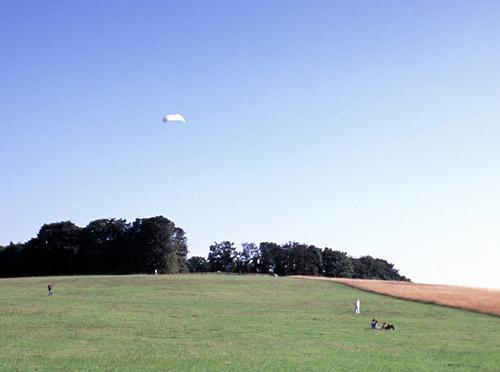How many kites are there?
Give a very brief answer. 1. 